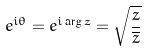Convert formula to latex. <formula><loc_0><loc_0><loc_500><loc_500>e ^ { i \theta } = e ^ { i \arg z } = \sqrt { \frac { z } { \overline { z } } }</formula> 